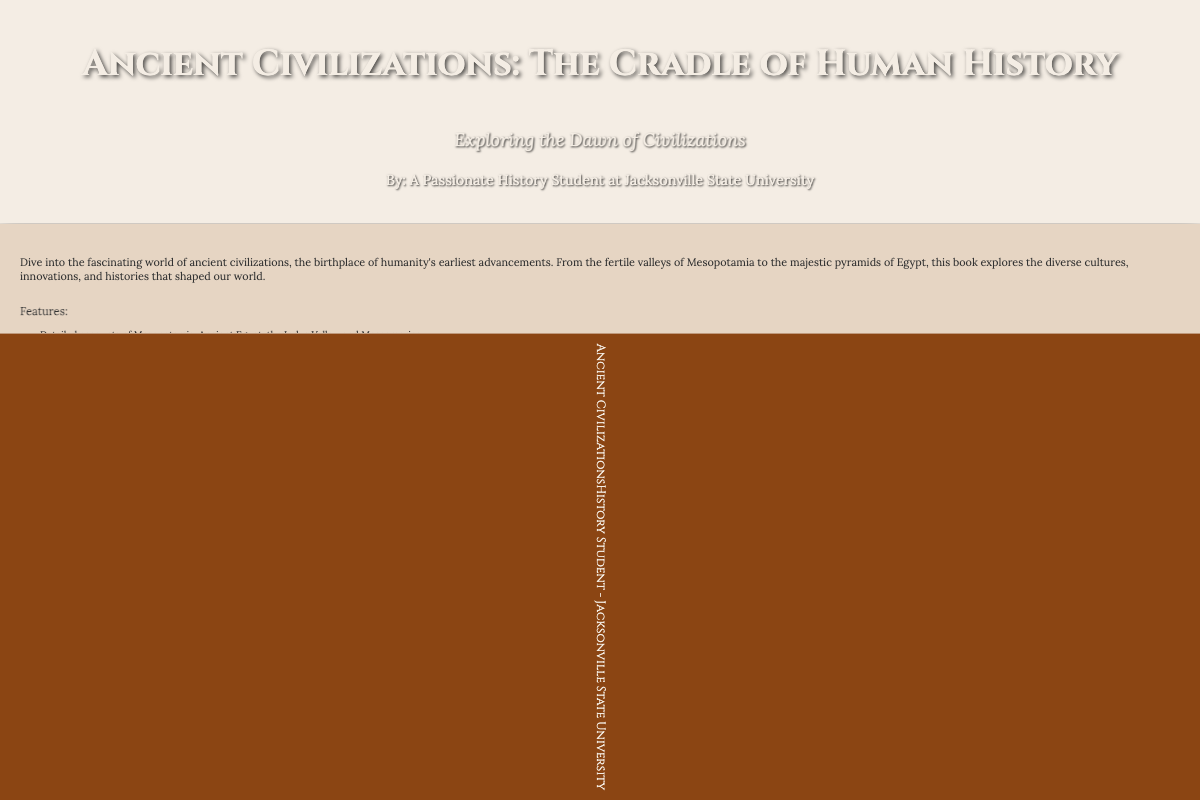What is the title of the book? The title of the book is prominently displayed on the front cover, which identifies it as "Ancient Civilizations: The Cradle of Human History."
Answer: Ancient Civilizations: The Cradle of Human History Who is the author of the book? The author is listed on the front cover as "A Passionate History Student at Jacksonville State University."
Answer: A Passionate History Student at Jacksonville State University What is the subtitle of the book? The subtitle, found below the title, reflects the main focus of the book as "Exploring the Dawn of Civilizations."
Answer: Exploring the Dawn of Civilizations How many features are listed in the back cover? The features section includes a list with four specific features related to the content of the book.
Answer: Four Which ancient civilization is mentioned first in the features? The first ancient civilization mentioned in the features section is Mesopotamia.
Answer: Mesopotamia Who provided a quote on the book's back cover? The quotes section includes a notable quote from "Dr. Jane Doe, Professor of Ancient History."
Answer: Dr. Jane Doe What type of book is this? The document presents itself as a book cover, which is indicated through its layout and design elements.
Answer: Book 